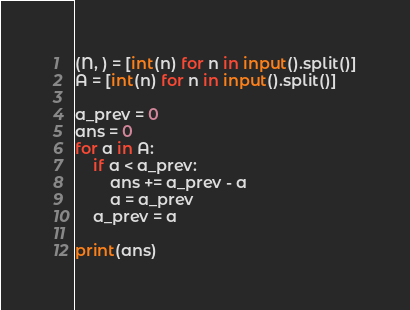<code> <loc_0><loc_0><loc_500><loc_500><_Python_>(N, ) = [int(n) for n in input().split()]
A = [int(n) for n in input().split()]

a_prev = 0
ans = 0
for a in A:
    if a < a_prev:
        ans += a_prev - a
        a = a_prev
    a_prev = a

print(ans)
</code> 